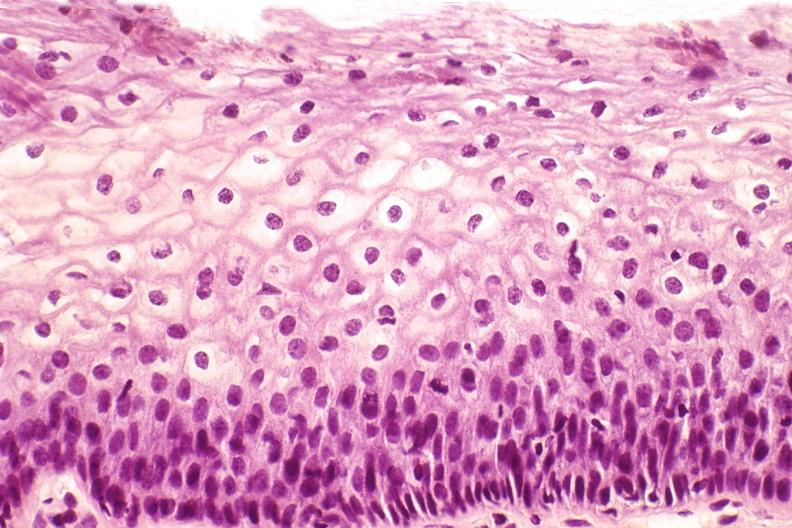what does this image show?
Answer the question using a single word or phrase. Cervix 